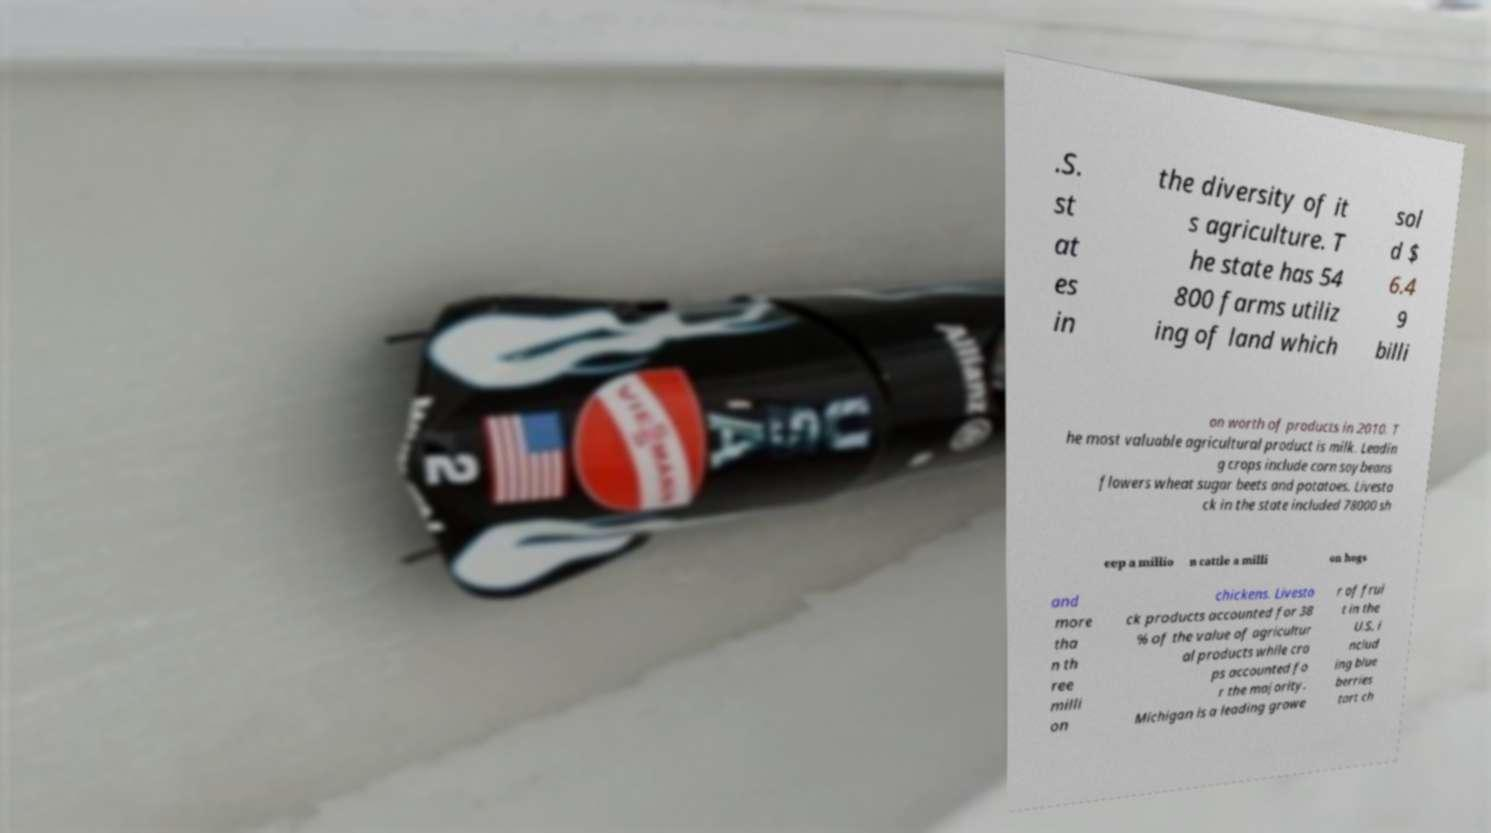Can you read and provide the text displayed in the image?This photo seems to have some interesting text. Can you extract and type it out for me? .S. st at es in the diversity of it s agriculture. T he state has 54 800 farms utiliz ing of land which sol d $ 6.4 9 billi on worth of products in 2010. T he most valuable agricultural product is milk. Leadin g crops include corn soybeans flowers wheat sugar beets and potatoes. Livesto ck in the state included 78000 sh eep a millio n cattle a milli on hogs and more tha n th ree milli on chickens. Livesto ck products accounted for 38 % of the value of agricultur al products while cro ps accounted fo r the majority. Michigan is a leading growe r of frui t in the U.S. i nclud ing blue berries tart ch 